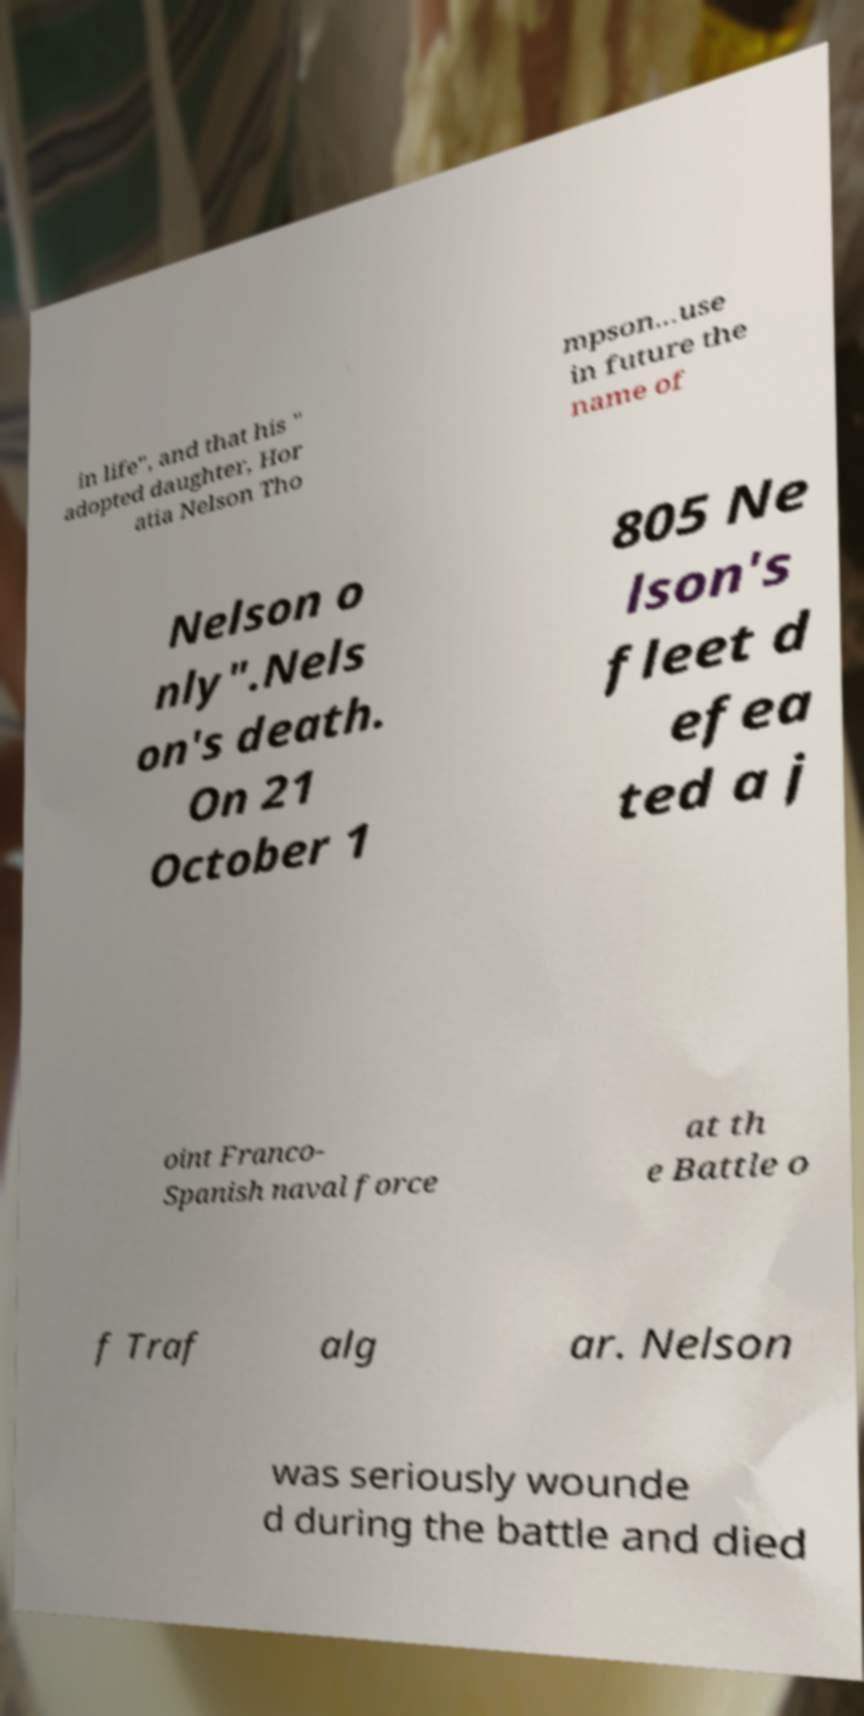I need the written content from this picture converted into text. Can you do that? in life", and that his " adopted daughter, Hor atia Nelson Tho mpson...use in future the name of Nelson o nly".Nels on's death. On 21 October 1 805 Ne lson's fleet d efea ted a j oint Franco- Spanish naval force at th e Battle o f Traf alg ar. Nelson was seriously wounde d during the battle and died 